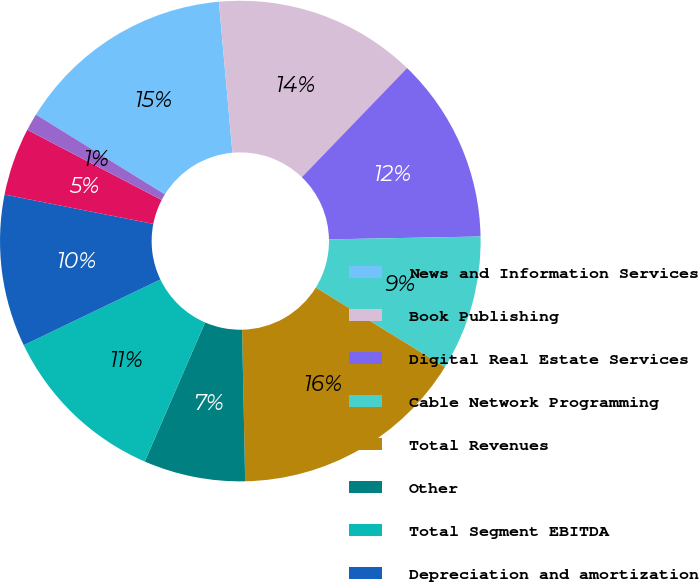<chart> <loc_0><loc_0><loc_500><loc_500><pie_chart><fcel>News and Information Services<fcel>Book Publishing<fcel>Digital Real Estate Services<fcel>Cable Network Programming<fcel>Total Revenues<fcel>Other<fcel>Total Segment EBITDA<fcel>Depreciation and amortization<fcel>Impairment and restructuring<fcel>Equity earnings of affiliates<nl><fcel>14.76%<fcel>13.63%<fcel>12.49%<fcel>9.09%<fcel>15.89%<fcel>6.83%<fcel>11.36%<fcel>10.23%<fcel>4.56%<fcel>1.16%<nl></chart> 